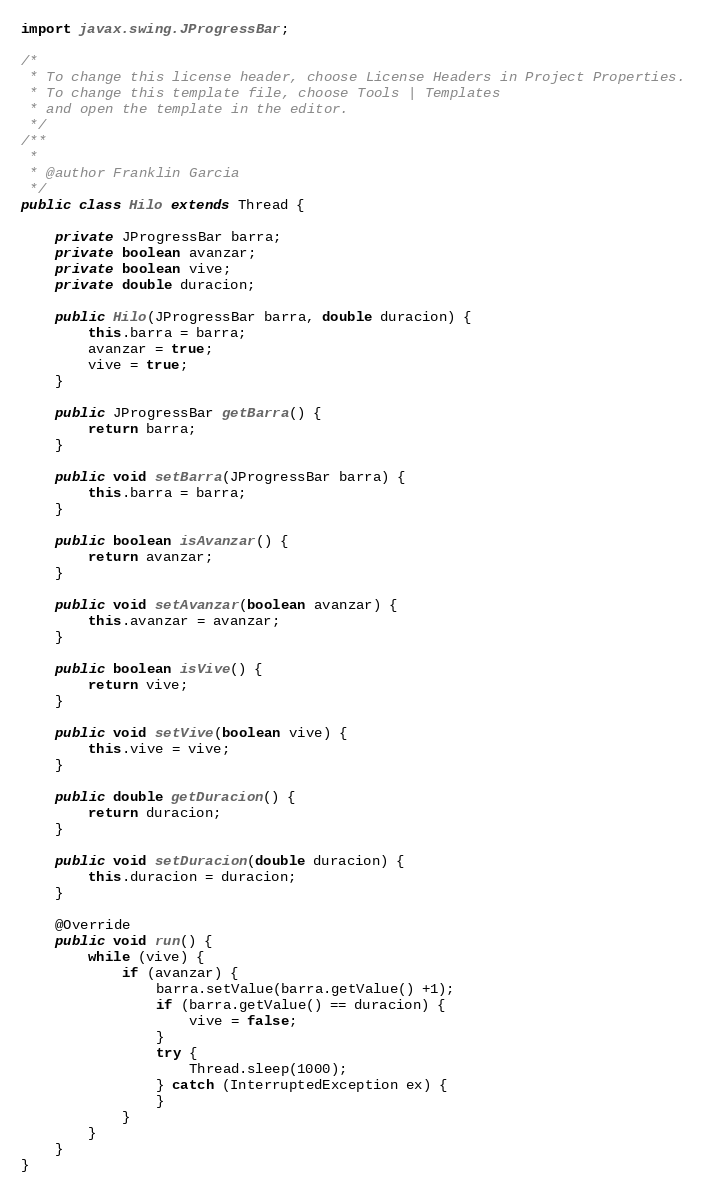Convert code to text. <code><loc_0><loc_0><loc_500><loc_500><_Java_>
import javax.swing.JProgressBar;

/*
 * To change this license header, choose License Headers in Project Properties.
 * To change this template file, choose Tools | Templates
 * and open the template in the editor.
 */
/**
 *
 * @author Franklin Garcia
 */
public class Hilo extends Thread {

    private JProgressBar barra;
    private boolean avanzar;
    private boolean vive;
    private double duracion;

    public Hilo(JProgressBar barra, double duracion) {
        this.barra = barra;
        avanzar = true;
        vive = true;
    }

    public JProgressBar getBarra() {
        return barra;
    }

    public void setBarra(JProgressBar barra) {
        this.barra = barra;
    }

    public boolean isAvanzar() {
        return avanzar;
    }

    public void setAvanzar(boolean avanzar) {
        this.avanzar = avanzar;
    }

    public boolean isVive() {
        return vive;
    }

    public void setVive(boolean vive) {
        this.vive = vive;
    }

    public double getDuracion() {
        return duracion;
    }

    public void setDuracion(double duracion) {
        this.duracion = duracion;
    }

    @Override
    public void run() {
        while (vive) {
            if (avanzar) {
                barra.setValue(barra.getValue() +1);
                if (barra.getValue() == duracion) {
                    vive = false;
                }
                try {
                    Thread.sleep(1000);
                } catch (InterruptedException ex) {
                }
            }
        }
    }
}
</code> 